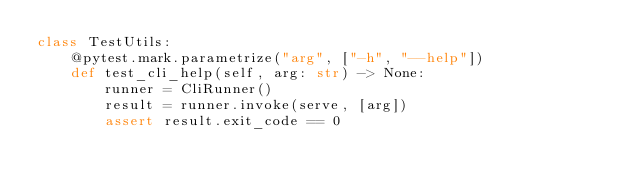<code> <loc_0><loc_0><loc_500><loc_500><_Python_>class TestUtils:
    @pytest.mark.parametrize("arg", ["-h", "--help"])
    def test_cli_help(self, arg: str) -> None:
        runner = CliRunner()
        result = runner.invoke(serve, [arg])
        assert result.exit_code == 0
</code> 